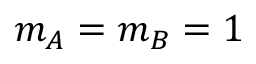<formula> <loc_0><loc_0><loc_500><loc_500>m _ { A } = m _ { B } = 1</formula> 